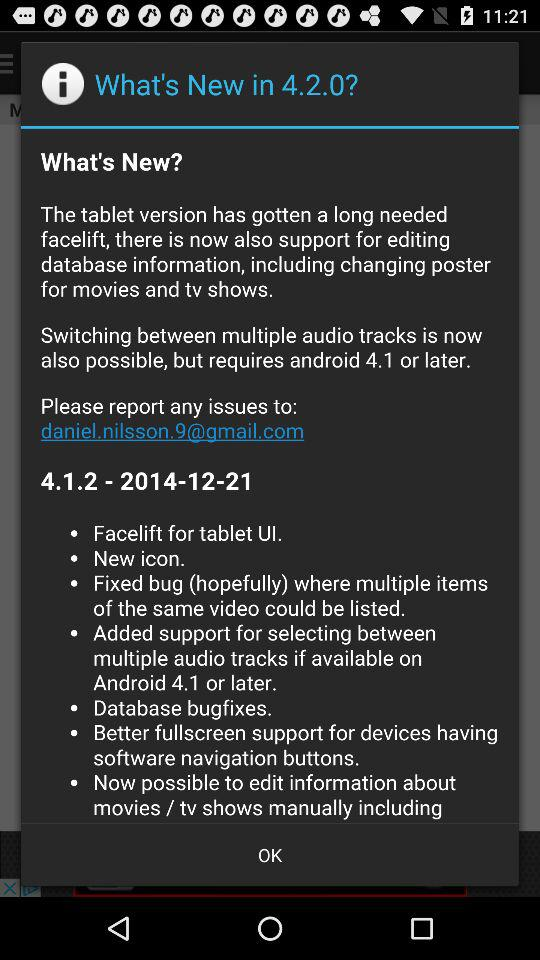What is the date? The date is 2014-12-21. 